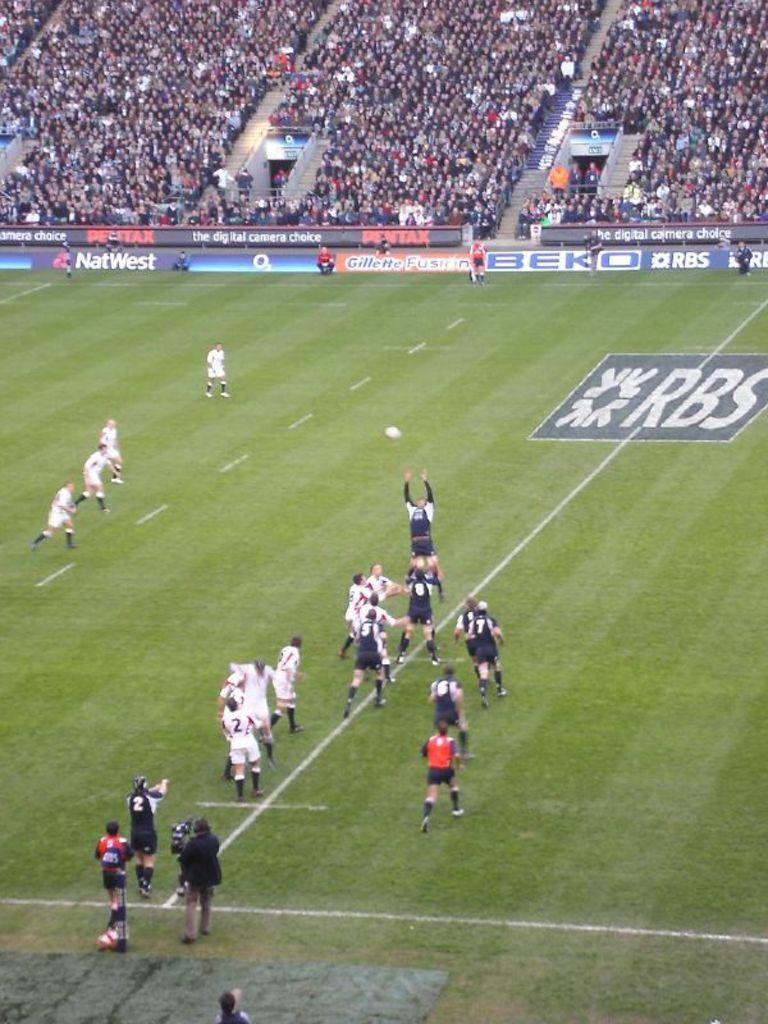What is the sponsor of the team?
Provide a succinct answer. Rbs. Which company is advertised on the dark blue banner?
Offer a very short reply. Rbs. 